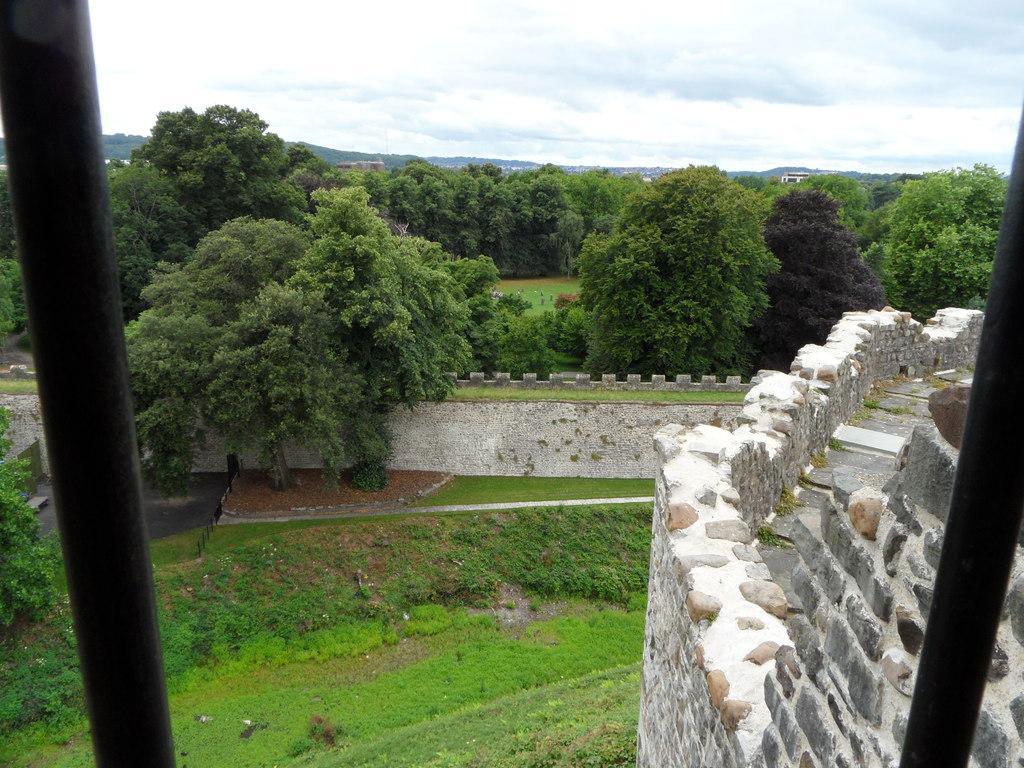Describe this image in one or two sentences. On the left side, there is a black color pole. On the right side, there is another black color pole near the brick wall on which, there are stones arranged. In the background, there is grass, there are plants and trees on the ground, there is a wall, a mountain and there is sky. 